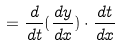Convert formula to latex. <formula><loc_0><loc_0><loc_500><loc_500>= \frac { d } { d t } ( \frac { d y } { d x } ) \cdot \frac { d t } { d x }</formula> 